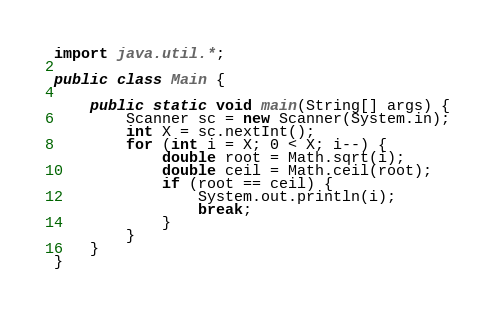Convert code to text. <code><loc_0><loc_0><loc_500><loc_500><_Java_>import java.util.*;
 
public class Main {
	
    public static void main(String[] args) {
    	Scanner sc = new Scanner(System.in);
    	int X = sc.nextInt();
    	for (int i = X; 0 < X; i--) {
    		double root = Math.sqrt(i);
    		double ceil = Math.ceil(root);
    		if (root == ceil) {
    			System.out.println(i);
    			break;
    		}
    	}
    }
}</code> 